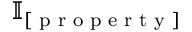<formula> <loc_0><loc_0><loc_500><loc_500>\mathbb { I } _ { [ p r o p e r t y ] }</formula> 